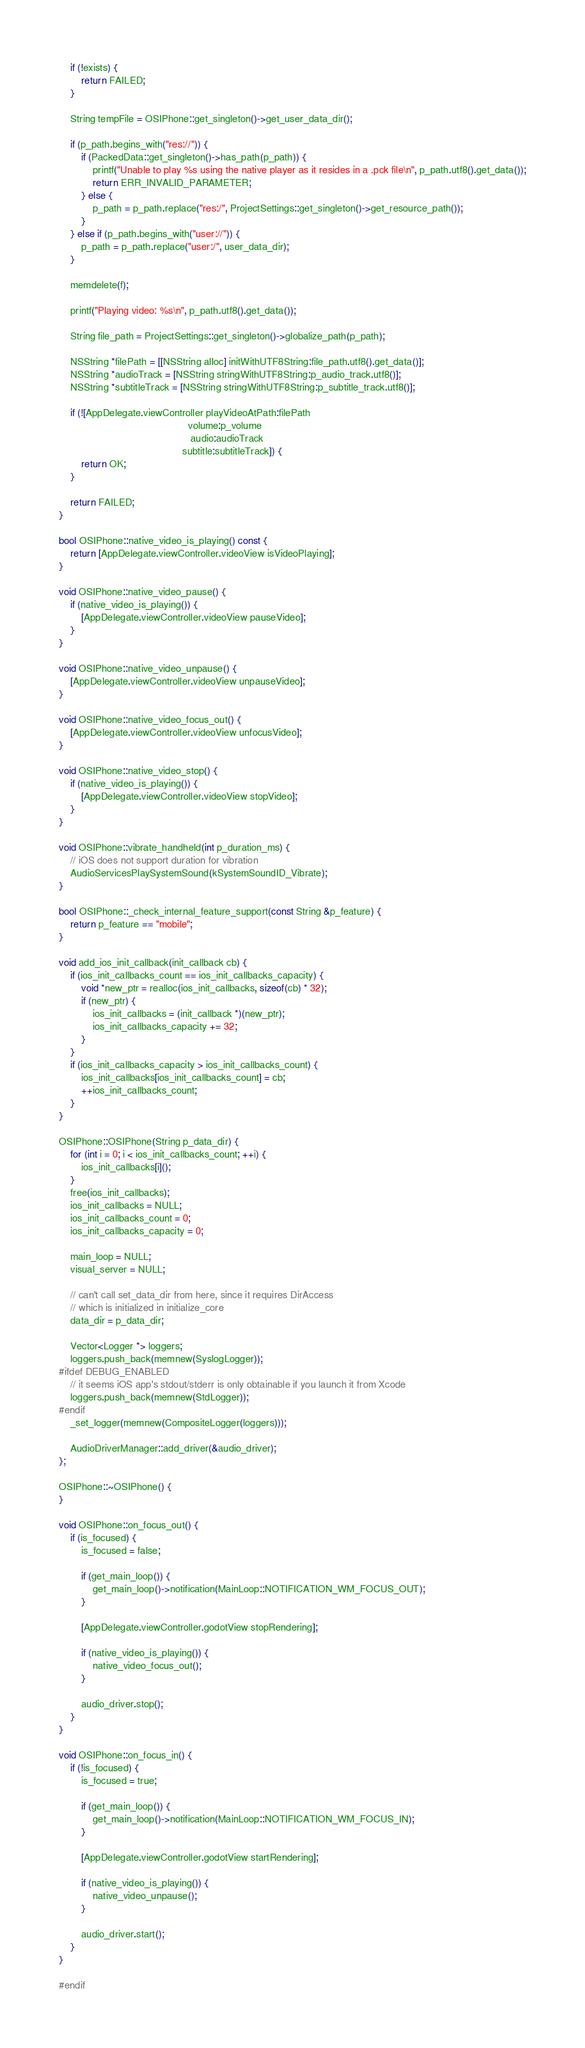<code> <loc_0><loc_0><loc_500><loc_500><_ObjectiveC_>	if (!exists) {
		return FAILED;
	}

	String tempFile = OSIPhone::get_singleton()->get_user_data_dir();

	if (p_path.begins_with("res://")) {
		if (PackedData::get_singleton()->has_path(p_path)) {
			printf("Unable to play %s using the native player as it resides in a .pck file\n", p_path.utf8().get_data());
			return ERR_INVALID_PARAMETER;
		} else {
			p_path = p_path.replace("res:/", ProjectSettings::get_singleton()->get_resource_path());
		}
	} else if (p_path.begins_with("user://")) {
		p_path = p_path.replace("user:/", user_data_dir);
	}

	memdelete(f);

	printf("Playing video: %s\n", p_path.utf8().get_data());

	String file_path = ProjectSettings::get_singleton()->globalize_path(p_path);

	NSString *filePath = [[NSString alloc] initWithUTF8String:file_path.utf8().get_data()];
	NSString *audioTrack = [NSString stringWithUTF8String:p_audio_track.utf8()];
	NSString *subtitleTrack = [NSString stringWithUTF8String:p_subtitle_track.utf8()];

	if (![AppDelegate.viewController playVideoAtPath:filePath
											  volume:p_volume
											   audio:audioTrack
											subtitle:subtitleTrack]) {
		return OK;
	}

	return FAILED;
}

bool OSIPhone::native_video_is_playing() const {
	return [AppDelegate.viewController.videoView isVideoPlaying];
}

void OSIPhone::native_video_pause() {
	if (native_video_is_playing()) {
		[AppDelegate.viewController.videoView pauseVideo];
	}
}

void OSIPhone::native_video_unpause() {
	[AppDelegate.viewController.videoView unpauseVideo];
}

void OSIPhone::native_video_focus_out() {
	[AppDelegate.viewController.videoView unfocusVideo];
}

void OSIPhone::native_video_stop() {
	if (native_video_is_playing()) {
		[AppDelegate.viewController.videoView stopVideo];
	}
}

void OSIPhone::vibrate_handheld(int p_duration_ms) {
	// iOS does not support duration for vibration
	AudioServicesPlaySystemSound(kSystemSoundID_Vibrate);
}

bool OSIPhone::_check_internal_feature_support(const String &p_feature) {
	return p_feature == "mobile";
}

void add_ios_init_callback(init_callback cb) {
	if (ios_init_callbacks_count == ios_init_callbacks_capacity) {
		void *new_ptr = realloc(ios_init_callbacks, sizeof(cb) * 32);
		if (new_ptr) {
			ios_init_callbacks = (init_callback *)(new_ptr);
			ios_init_callbacks_capacity += 32;
		}
	}
	if (ios_init_callbacks_capacity > ios_init_callbacks_count) {
		ios_init_callbacks[ios_init_callbacks_count] = cb;
		++ios_init_callbacks_count;
	}
}

OSIPhone::OSIPhone(String p_data_dir) {
	for (int i = 0; i < ios_init_callbacks_count; ++i) {
		ios_init_callbacks[i]();
	}
	free(ios_init_callbacks);
	ios_init_callbacks = NULL;
	ios_init_callbacks_count = 0;
	ios_init_callbacks_capacity = 0;

	main_loop = NULL;
	visual_server = NULL;

	// can't call set_data_dir from here, since it requires DirAccess
	// which is initialized in initialize_core
	data_dir = p_data_dir;

	Vector<Logger *> loggers;
	loggers.push_back(memnew(SyslogLogger));
#ifdef DEBUG_ENABLED
	// it seems iOS app's stdout/stderr is only obtainable if you launch it from Xcode
	loggers.push_back(memnew(StdLogger));
#endif
	_set_logger(memnew(CompositeLogger(loggers)));

	AudioDriverManager::add_driver(&audio_driver);
};

OSIPhone::~OSIPhone() {
}

void OSIPhone::on_focus_out() {
	if (is_focused) {
		is_focused = false;

		if (get_main_loop()) {
			get_main_loop()->notification(MainLoop::NOTIFICATION_WM_FOCUS_OUT);
		}

		[AppDelegate.viewController.godotView stopRendering];

		if (native_video_is_playing()) {
			native_video_focus_out();
		}

		audio_driver.stop();
	}
}

void OSIPhone::on_focus_in() {
	if (!is_focused) {
		is_focused = true;

		if (get_main_loop()) {
			get_main_loop()->notification(MainLoop::NOTIFICATION_WM_FOCUS_IN);
		}

		[AppDelegate.viewController.godotView startRendering];

		if (native_video_is_playing()) {
			native_video_unpause();
		}

		audio_driver.start();
	}
}

#endif
</code> 